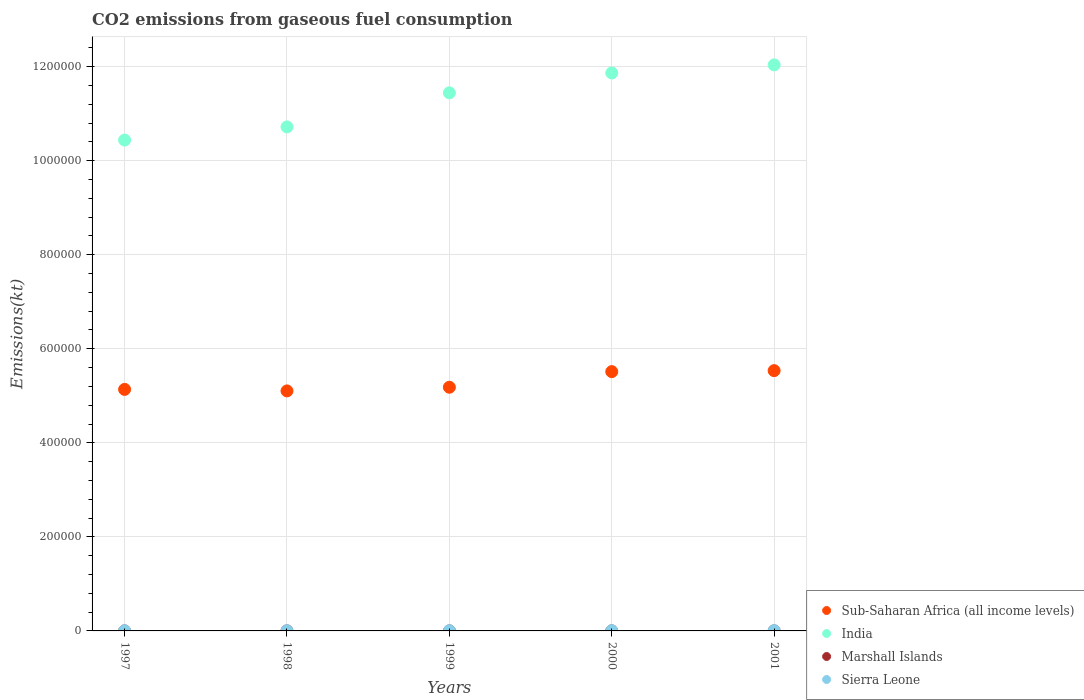How many different coloured dotlines are there?
Provide a succinct answer. 4. What is the amount of CO2 emitted in Sierra Leone in 2001?
Ensure brevity in your answer.  568.38. Across all years, what is the maximum amount of CO2 emitted in Marshall Islands?
Your answer should be very brief. 80.67. Across all years, what is the minimum amount of CO2 emitted in India?
Give a very brief answer. 1.04e+06. In which year was the amount of CO2 emitted in Sierra Leone maximum?
Ensure brevity in your answer.  2001. In which year was the amount of CO2 emitted in Marshall Islands minimum?
Give a very brief answer. 1997. What is the total amount of CO2 emitted in Marshall Islands in the graph?
Keep it short and to the point. 359.37. What is the difference between the amount of CO2 emitted in Marshall Islands in 1997 and that in 2000?
Your response must be concise. -11. What is the difference between the amount of CO2 emitted in Marshall Islands in 1997 and the amount of CO2 emitted in Sub-Saharan Africa (all income levels) in 2000?
Keep it short and to the point. -5.51e+05. What is the average amount of CO2 emitted in Marshall Islands per year?
Keep it short and to the point. 71.87. In the year 2001, what is the difference between the amount of CO2 emitted in India and amount of CO2 emitted in Sub-Saharan Africa (all income levels)?
Your answer should be compact. 6.50e+05. What is the ratio of the amount of CO2 emitted in Sub-Saharan Africa (all income levels) in 1998 to that in 2000?
Your answer should be compact. 0.93. Is the amount of CO2 emitted in Sierra Leone in 1999 less than that in 2001?
Provide a short and direct response. Yes. What is the difference between the highest and the second highest amount of CO2 emitted in Sierra Leone?
Your response must be concise. 143.01. What is the difference between the highest and the lowest amount of CO2 emitted in Marshall Islands?
Provide a short and direct response. 14.67. Is the sum of the amount of CO2 emitted in Sub-Saharan Africa (all income levels) in 1999 and 2000 greater than the maximum amount of CO2 emitted in Sierra Leone across all years?
Offer a terse response. Yes. Is it the case that in every year, the sum of the amount of CO2 emitted in India and amount of CO2 emitted in Sub-Saharan Africa (all income levels)  is greater than the sum of amount of CO2 emitted in Marshall Islands and amount of CO2 emitted in Sierra Leone?
Make the answer very short. Yes. Is it the case that in every year, the sum of the amount of CO2 emitted in Sub-Saharan Africa (all income levels) and amount of CO2 emitted in Sierra Leone  is greater than the amount of CO2 emitted in India?
Make the answer very short. No. Is the amount of CO2 emitted in Marshall Islands strictly less than the amount of CO2 emitted in Sub-Saharan Africa (all income levels) over the years?
Offer a very short reply. Yes. How many dotlines are there?
Make the answer very short. 4. How many years are there in the graph?
Your response must be concise. 5. What is the difference between two consecutive major ticks on the Y-axis?
Keep it short and to the point. 2.00e+05. Does the graph contain any zero values?
Make the answer very short. No. Where does the legend appear in the graph?
Your answer should be very brief. Bottom right. How many legend labels are there?
Make the answer very short. 4. How are the legend labels stacked?
Offer a terse response. Vertical. What is the title of the graph?
Ensure brevity in your answer.  CO2 emissions from gaseous fuel consumption. Does "Sweden" appear as one of the legend labels in the graph?
Your response must be concise. No. What is the label or title of the Y-axis?
Your answer should be compact. Emissions(kt). What is the Emissions(kt) in Sub-Saharan Africa (all income levels) in 1997?
Keep it short and to the point. 5.14e+05. What is the Emissions(kt) in India in 1997?
Ensure brevity in your answer.  1.04e+06. What is the Emissions(kt) in Marshall Islands in 1997?
Offer a terse response. 66.01. What is the Emissions(kt) in Sierra Leone in 1997?
Provide a short and direct response. 392.37. What is the Emissions(kt) in Sub-Saharan Africa (all income levels) in 1998?
Make the answer very short. 5.10e+05. What is the Emissions(kt) of India in 1998?
Provide a short and direct response. 1.07e+06. What is the Emissions(kt) in Marshall Islands in 1998?
Offer a very short reply. 69.67. What is the Emissions(kt) in Sierra Leone in 1998?
Ensure brevity in your answer.  366.7. What is the Emissions(kt) of Sub-Saharan Africa (all income levels) in 1999?
Your answer should be very brief. 5.18e+05. What is the Emissions(kt) in India in 1999?
Keep it short and to the point. 1.14e+06. What is the Emissions(kt) of Marshall Islands in 1999?
Give a very brief answer. 66.01. What is the Emissions(kt) of Sierra Leone in 1999?
Offer a very short reply. 352.03. What is the Emissions(kt) of Sub-Saharan Africa (all income levels) in 2000?
Your answer should be compact. 5.51e+05. What is the Emissions(kt) of India in 2000?
Provide a succinct answer. 1.19e+06. What is the Emissions(kt) in Marshall Islands in 2000?
Your answer should be compact. 77.01. What is the Emissions(kt) of Sierra Leone in 2000?
Provide a succinct answer. 425.37. What is the Emissions(kt) in Sub-Saharan Africa (all income levels) in 2001?
Provide a short and direct response. 5.54e+05. What is the Emissions(kt) of India in 2001?
Keep it short and to the point. 1.20e+06. What is the Emissions(kt) of Marshall Islands in 2001?
Offer a very short reply. 80.67. What is the Emissions(kt) of Sierra Leone in 2001?
Give a very brief answer. 568.38. Across all years, what is the maximum Emissions(kt) of Sub-Saharan Africa (all income levels)?
Ensure brevity in your answer.  5.54e+05. Across all years, what is the maximum Emissions(kt) in India?
Provide a succinct answer. 1.20e+06. Across all years, what is the maximum Emissions(kt) in Marshall Islands?
Make the answer very short. 80.67. Across all years, what is the maximum Emissions(kt) in Sierra Leone?
Ensure brevity in your answer.  568.38. Across all years, what is the minimum Emissions(kt) of Sub-Saharan Africa (all income levels)?
Offer a very short reply. 5.10e+05. Across all years, what is the minimum Emissions(kt) in India?
Keep it short and to the point. 1.04e+06. Across all years, what is the minimum Emissions(kt) of Marshall Islands?
Ensure brevity in your answer.  66.01. Across all years, what is the minimum Emissions(kt) in Sierra Leone?
Offer a terse response. 352.03. What is the total Emissions(kt) of Sub-Saharan Africa (all income levels) in the graph?
Keep it short and to the point. 2.65e+06. What is the total Emissions(kt) of India in the graph?
Provide a short and direct response. 5.65e+06. What is the total Emissions(kt) in Marshall Islands in the graph?
Your answer should be compact. 359.37. What is the total Emissions(kt) in Sierra Leone in the graph?
Offer a terse response. 2104.86. What is the difference between the Emissions(kt) in Sub-Saharan Africa (all income levels) in 1997 and that in 1998?
Offer a very short reply. 3200.52. What is the difference between the Emissions(kt) in India in 1997 and that in 1998?
Ensure brevity in your answer.  -2.80e+04. What is the difference between the Emissions(kt) in Marshall Islands in 1997 and that in 1998?
Give a very brief answer. -3.67. What is the difference between the Emissions(kt) of Sierra Leone in 1997 and that in 1998?
Offer a terse response. 25.67. What is the difference between the Emissions(kt) of Sub-Saharan Africa (all income levels) in 1997 and that in 1999?
Offer a terse response. -4576.38. What is the difference between the Emissions(kt) in India in 1997 and that in 1999?
Ensure brevity in your answer.  -1.00e+05. What is the difference between the Emissions(kt) in Sierra Leone in 1997 and that in 1999?
Make the answer very short. 40.34. What is the difference between the Emissions(kt) in Sub-Saharan Africa (all income levels) in 1997 and that in 2000?
Provide a short and direct response. -3.78e+04. What is the difference between the Emissions(kt) of India in 1997 and that in 2000?
Your answer should be compact. -1.43e+05. What is the difference between the Emissions(kt) of Marshall Islands in 1997 and that in 2000?
Offer a terse response. -11. What is the difference between the Emissions(kt) of Sierra Leone in 1997 and that in 2000?
Ensure brevity in your answer.  -33. What is the difference between the Emissions(kt) of Sub-Saharan Africa (all income levels) in 1997 and that in 2001?
Offer a terse response. -3.99e+04. What is the difference between the Emissions(kt) in India in 1997 and that in 2001?
Keep it short and to the point. -1.60e+05. What is the difference between the Emissions(kt) in Marshall Islands in 1997 and that in 2001?
Keep it short and to the point. -14.67. What is the difference between the Emissions(kt) of Sierra Leone in 1997 and that in 2001?
Your answer should be very brief. -176.02. What is the difference between the Emissions(kt) in Sub-Saharan Africa (all income levels) in 1998 and that in 1999?
Offer a terse response. -7776.91. What is the difference between the Emissions(kt) of India in 1998 and that in 1999?
Offer a terse response. -7.25e+04. What is the difference between the Emissions(kt) in Marshall Islands in 1998 and that in 1999?
Give a very brief answer. 3.67. What is the difference between the Emissions(kt) in Sierra Leone in 1998 and that in 1999?
Give a very brief answer. 14.67. What is the difference between the Emissions(kt) in Sub-Saharan Africa (all income levels) in 1998 and that in 2000?
Your answer should be very brief. -4.10e+04. What is the difference between the Emissions(kt) in India in 1998 and that in 2000?
Provide a short and direct response. -1.15e+05. What is the difference between the Emissions(kt) of Marshall Islands in 1998 and that in 2000?
Offer a very short reply. -7.33. What is the difference between the Emissions(kt) in Sierra Leone in 1998 and that in 2000?
Make the answer very short. -58.67. What is the difference between the Emissions(kt) of Sub-Saharan Africa (all income levels) in 1998 and that in 2001?
Make the answer very short. -4.31e+04. What is the difference between the Emissions(kt) in India in 1998 and that in 2001?
Provide a short and direct response. -1.32e+05. What is the difference between the Emissions(kt) of Marshall Islands in 1998 and that in 2001?
Your answer should be very brief. -11. What is the difference between the Emissions(kt) of Sierra Leone in 1998 and that in 2001?
Offer a very short reply. -201.69. What is the difference between the Emissions(kt) of Sub-Saharan Africa (all income levels) in 1999 and that in 2000?
Offer a terse response. -3.32e+04. What is the difference between the Emissions(kt) in India in 1999 and that in 2000?
Offer a very short reply. -4.23e+04. What is the difference between the Emissions(kt) of Marshall Islands in 1999 and that in 2000?
Provide a short and direct response. -11. What is the difference between the Emissions(kt) in Sierra Leone in 1999 and that in 2000?
Ensure brevity in your answer.  -73.34. What is the difference between the Emissions(kt) of Sub-Saharan Africa (all income levels) in 1999 and that in 2001?
Provide a succinct answer. -3.53e+04. What is the difference between the Emissions(kt) of India in 1999 and that in 2001?
Provide a succinct answer. -5.95e+04. What is the difference between the Emissions(kt) in Marshall Islands in 1999 and that in 2001?
Your answer should be very brief. -14.67. What is the difference between the Emissions(kt) of Sierra Leone in 1999 and that in 2001?
Your answer should be very brief. -216.35. What is the difference between the Emissions(kt) in Sub-Saharan Africa (all income levels) in 2000 and that in 2001?
Your answer should be compact. -2116.98. What is the difference between the Emissions(kt) in India in 2000 and that in 2001?
Provide a short and direct response. -1.72e+04. What is the difference between the Emissions(kt) of Marshall Islands in 2000 and that in 2001?
Offer a terse response. -3.67. What is the difference between the Emissions(kt) of Sierra Leone in 2000 and that in 2001?
Provide a short and direct response. -143.01. What is the difference between the Emissions(kt) in Sub-Saharan Africa (all income levels) in 1997 and the Emissions(kt) in India in 1998?
Keep it short and to the point. -5.58e+05. What is the difference between the Emissions(kt) of Sub-Saharan Africa (all income levels) in 1997 and the Emissions(kt) of Marshall Islands in 1998?
Keep it short and to the point. 5.14e+05. What is the difference between the Emissions(kt) of Sub-Saharan Africa (all income levels) in 1997 and the Emissions(kt) of Sierra Leone in 1998?
Provide a succinct answer. 5.13e+05. What is the difference between the Emissions(kt) in India in 1997 and the Emissions(kt) in Marshall Islands in 1998?
Provide a succinct answer. 1.04e+06. What is the difference between the Emissions(kt) of India in 1997 and the Emissions(kt) of Sierra Leone in 1998?
Your answer should be compact. 1.04e+06. What is the difference between the Emissions(kt) in Marshall Islands in 1997 and the Emissions(kt) in Sierra Leone in 1998?
Give a very brief answer. -300.69. What is the difference between the Emissions(kt) of Sub-Saharan Africa (all income levels) in 1997 and the Emissions(kt) of India in 1999?
Offer a very short reply. -6.31e+05. What is the difference between the Emissions(kt) in Sub-Saharan Africa (all income levels) in 1997 and the Emissions(kt) in Marshall Islands in 1999?
Your answer should be very brief. 5.14e+05. What is the difference between the Emissions(kt) in Sub-Saharan Africa (all income levels) in 1997 and the Emissions(kt) in Sierra Leone in 1999?
Provide a succinct answer. 5.13e+05. What is the difference between the Emissions(kt) of India in 1997 and the Emissions(kt) of Marshall Islands in 1999?
Provide a succinct answer. 1.04e+06. What is the difference between the Emissions(kt) of India in 1997 and the Emissions(kt) of Sierra Leone in 1999?
Make the answer very short. 1.04e+06. What is the difference between the Emissions(kt) in Marshall Islands in 1997 and the Emissions(kt) in Sierra Leone in 1999?
Offer a terse response. -286.03. What is the difference between the Emissions(kt) of Sub-Saharan Africa (all income levels) in 1997 and the Emissions(kt) of India in 2000?
Make the answer very short. -6.73e+05. What is the difference between the Emissions(kt) in Sub-Saharan Africa (all income levels) in 1997 and the Emissions(kt) in Marshall Islands in 2000?
Ensure brevity in your answer.  5.14e+05. What is the difference between the Emissions(kt) in Sub-Saharan Africa (all income levels) in 1997 and the Emissions(kt) in Sierra Leone in 2000?
Give a very brief answer. 5.13e+05. What is the difference between the Emissions(kt) of India in 1997 and the Emissions(kt) of Marshall Islands in 2000?
Keep it short and to the point. 1.04e+06. What is the difference between the Emissions(kt) of India in 1997 and the Emissions(kt) of Sierra Leone in 2000?
Make the answer very short. 1.04e+06. What is the difference between the Emissions(kt) of Marshall Islands in 1997 and the Emissions(kt) of Sierra Leone in 2000?
Make the answer very short. -359.37. What is the difference between the Emissions(kt) in Sub-Saharan Africa (all income levels) in 1997 and the Emissions(kt) in India in 2001?
Your answer should be compact. -6.90e+05. What is the difference between the Emissions(kt) of Sub-Saharan Africa (all income levels) in 1997 and the Emissions(kt) of Marshall Islands in 2001?
Give a very brief answer. 5.14e+05. What is the difference between the Emissions(kt) in Sub-Saharan Africa (all income levels) in 1997 and the Emissions(kt) in Sierra Leone in 2001?
Ensure brevity in your answer.  5.13e+05. What is the difference between the Emissions(kt) in India in 1997 and the Emissions(kt) in Marshall Islands in 2001?
Give a very brief answer. 1.04e+06. What is the difference between the Emissions(kt) in India in 1997 and the Emissions(kt) in Sierra Leone in 2001?
Make the answer very short. 1.04e+06. What is the difference between the Emissions(kt) of Marshall Islands in 1997 and the Emissions(kt) of Sierra Leone in 2001?
Ensure brevity in your answer.  -502.38. What is the difference between the Emissions(kt) in Sub-Saharan Africa (all income levels) in 1998 and the Emissions(kt) in India in 1999?
Provide a succinct answer. -6.34e+05. What is the difference between the Emissions(kt) of Sub-Saharan Africa (all income levels) in 1998 and the Emissions(kt) of Marshall Islands in 1999?
Provide a succinct answer. 5.10e+05. What is the difference between the Emissions(kt) in Sub-Saharan Africa (all income levels) in 1998 and the Emissions(kt) in Sierra Leone in 1999?
Your answer should be compact. 5.10e+05. What is the difference between the Emissions(kt) in India in 1998 and the Emissions(kt) in Marshall Islands in 1999?
Your answer should be compact. 1.07e+06. What is the difference between the Emissions(kt) in India in 1998 and the Emissions(kt) in Sierra Leone in 1999?
Your response must be concise. 1.07e+06. What is the difference between the Emissions(kt) of Marshall Islands in 1998 and the Emissions(kt) of Sierra Leone in 1999?
Provide a short and direct response. -282.36. What is the difference between the Emissions(kt) of Sub-Saharan Africa (all income levels) in 1998 and the Emissions(kt) of India in 2000?
Provide a succinct answer. -6.76e+05. What is the difference between the Emissions(kt) of Sub-Saharan Africa (all income levels) in 1998 and the Emissions(kt) of Marshall Islands in 2000?
Your response must be concise. 5.10e+05. What is the difference between the Emissions(kt) in Sub-Saharan Africa (all income levels) in 1998 and the Emissions(kt) in Sierra Leone in 2000?
Give a very brief answer. 5.10e+05. What is the difference between the Emissions(kt) in India in 1998 and the Emissions(kt) in Marshall Islands in 2000?
Keep it short and to the point. 1.07e+06. What is the difference between the Emissions(kt) of India in 1998 and the Emissions(kt) of Sierra Leone in 2000?
Make the answer very short. 1.07e+06. What is the difference between the Emissions(kt) of Marshall Islands in 1998 and the Emissions(kt) of Sierra Leone in 2000?
Give a very brief answer. -355.7. What is the difference between the Emissions(kt) of Sub-Saharan Africa (all income levels) in 1998 and the Emissions(kt) of India in 2001?
Keep it short and to the point. -6.93e+05. What is the difference between the Emissions(kt) in Sub-Saharan Africa (all income levels) in 1998 and the Emissions(kt) in Marshall Islands in 2001?
Provide a succinct answer. 5.10e+05. What is the difference between the Emissions(kt) in Sub-Saharan Africa (all income levels) in 1998 and the Emissions(kt) in Sierra Leone in 2001?
Keep it short and to the point. 5.10e+05. What is the difference between the Emissions(kt) in India in 1998 and the Emissions(kt) in Marshall Islands in 2001?
Keep it short and to the point. 1.07e+06. What is the difference between the Emissions(kt) of India in 1998 and the Emissions(kt) of Sierra Leone in 2001?
Give a very brief answer. 1.07e+06. What is the difference between the Emissions(kt) of Marshall Islands in 1998 and the Emissions(kt) of Sierra Leone in 2001?
Keep it short and to the point. -498.71. What is the difference between the Emissions(kt) of Sub-Saharan Africa (all income levels) in 1999 and the Emissions(kt) of India in 2000?
Keep it short and to the point. -6.68e+05. What is the difference between the Emissions(kt) in Sub-Saharan Africa (all income levels) in 1999 and the Emissions(kt) in Marshall Islands in 2000?
Ensure brevity in your answer.  5.18e+05. What is the difference between the Emissions(kt) of Sub-Saharan Africa (all income levels) in 1999 and the Emissions(kt) of Sierra Leone in 2000?
Keep it short and to the point. 5.18e+05. What is the difference between the Emissions(kt) of India in 1999 and the Emissions(kt) of Marshall Islands in 2000?
Your answer should be compact. 1.14e+06. What is the difference between the Emissions(kt) in India in 1999 and the Emissions(kt) in Sierra Leone in 2000?
Your response must be concise. 1.14e+06. What is the difference between the Emissions(kt) of Marshall Islands in 1999 and the Emissions(kt) of Sierra Leone in 2000?
Provide a short and direct response. -359.37. What is the difference between the Emissions(kt) of Sub-Saharan Africa (all income levels) in 1999 and the Emissions(kt) of India in 2001?
Ensure brevity in your answer.  -6.86e+05. What is the difference between the Emissions(kt) in Sub-Saharan Africa (all income levels) in 1999 and the Emissions(kt) in Marshall Islands in 2001?
Offer a terse response. 5.18e+05. What is the difference between the Emissions(kt) in Sub-Saharan Africa (all income levels) in 1999 and the Emissions(kt) in Sierra Leone in 2001?
Your answer should be very brief. 5.18e+05. What is the difference between the Emissions(kt) of India in 1999 and the Emissions(kt) of Marshall Islands in 2001?
Make the answer very short. 1.14e+06. What is the difference between the Emissions(kt) in India in 1999 and the Emissions(kt) in Sierra Leone in 2001?
Ensure brevity in your answer.  1.14e+06. What is the difference between the Emissions(kt) in Marshall Islands in 1999 and the Emissions(kt) in Sierra Leone in 2001?
Make the answer very short. -502.38. What is the difference between the Emissions(kt) of Sub-Saharan Africa (all income levels) in 2000 and the Emissions(kt) of India in 2001?
Your answer should be compact. -6.52e+05. What is the difference between the Emissions(kt) of Sub-Saharan Africa (all income levels) in 2000 and the Emissions(kt) of Marshall Islands in 2001?
Your response must be concise. 5.51e+05. What is the difference between the Emissions(kt) in Sub-Saharan Africa (all income levels) in 2000 and the Emissions(kt) in Sierra Leone in 2001?
Offer a terse response. 5.51e+05. What is the difference between the Emissions(kt) of India in 2000 and the Emissions(kt) of Marshall Islands in 2001?
Provide a short and direct response. 1.19e+06. What is the difference between the Emissions(kt) of India in 2000 and the Emissions(kt) of Sierra Leone in 2001?
Your response must be concise. 1.19e+06. What is the difference between the Emissions(kt) of Marshall Islands in 2000 and the Emissions(kt) of Sierra Leone in 2001?
Ensure brevity in your answer.  -491.38. What is the average Emissions(kt) in Sub-Saharan Africa (all income levels) per year?
Ensure brevity in your answer.  5.29e+05. What is the average Emissions(kt) in India per year?
Ensure brevity in your answer.  1.13e+06. What is the average Emissions(kt) of Marshall Islands per year?
Your response must be concise. 71.87. What is the average Emissions(kt) of Sierra Leone per year?
Offer a terse response. 420.97. In the year 1997, what is the difference between the Emissions(kt) in Sub-Saharan Africa (all income levels) and Emissions(kt) in India?
Offer a very short reply. -5.30e+05. In the year 1997, what is the difference between the Emissions(kt) in Sub-Saharan Africa (all income levels) and Emissions(kt) in Marshall Islands?
Your answer should be compact. 5.14e+05. In the year 1997, what is the difference between the Emissions(kt) of Sub-Saharan Africa (all income levels) and Emissions(kt) of Sierra Leone?
Offer a very short reply. 5.13e+05. In the year 1997, what is the difference between the Emissions(kt) of India and Emissions(kt) of Marshall Islands?
Your answer should be very brief. 1.04e+06. In the year 1997, what is the difference between the Emissions(kt) in India and Emissions(kt) in Sierra Leone?
Your response must be concise. 1.04e+06. In the year 1997, what is the difference between the Emissions(kt) of Marshall Islands and Emissions(kt) of Sierra Leone?
Provide a succinct answer. -326.36. In the year 1998, what is the difference between the Emissions(kt) of Sub-Saharan Africa (all income levels) and Emissions(kt) of India?
Your answer should be very brief. -5.61e+05. In the year 1998, what is the difference between the Emissions(kt) in Sub-Saharan Africa (all income levels) and Emissions(kt) in Marshall Islands?
Offer a very short reply. 5.10e+05. In the year 1998, what is the difference between the Emissions(kt) in Sub-Saharan Africa (all income levels) and Emissions(kt) in Sierra Leone?
Give a very brief answer. 5.10e+05. In the year 1998, what is the difference between the Emissions(kt) of India and Emissions(kt) of Marshall Islands?
Ensure brevity in your answer.  1.07e+06. In the year 1998, what is the difference between the Emissions(kt) in India and Emissions(kt) in Sierra Leone?
Ensure brevity in your answer.  1.07e+06. In the year 1998, what is the difference between the Emissions(kt) of Marshall Islands and Emissions(kt) of Sierra Leone?
Offer a terse response. -297.03. In the year 1999, what is the difference between the Emissions(kt) of Sub-Saharan Africa (all income levels) and Emissions(kt) of India?
Your response must be concise. -6.26e+05. In the year 1999, what is the difference between the Emissions(kt) of Sub-Saharan Africa (all income levels) and Emissions(kt) of Marshall Islands?
Your answer should be very brief. 5.18e+05. In the year 1999, what is the difference between the Emissions(kt) in Sub-Saharan Africa (all income levels) and Emissions(kt) in Sierra Leone?
Offer a terse response. 5.18e+05. In the year 1999, what is the difference between the Emissions(kt) of India and Emissions(kt) of Marshall Islands?
Offer a very short reply. 1.14e+06. In the year 1999, what is the difference between the Emissions(kt) in India and Emissions(kt) in Sierra Leone?
Offer a very short reply. 1.14e+06. In the year 1999, what is the difference between the Emissions(kt) of Marshall Islands and Emissions(kt) of Sierra Leone?
Give a very brief answer. -286.03. In the year 2000, what is the difference between the Emissions(kt) in Sub-Saharan Africa (all income levels) and Emissions(kt) in India?
Your answer should be compact. -6.35e+05. In the year 2000, what is the difference between the Emissions(kt) in Sub-Saharan Africa (all income levels) and Emissions(kt) in Marshall Islands?
Offer a very short reply. 5.51e+05. In the year 2000, what is the difference between the Emissions(kt) in Sub-Saharan Africa (all income levels) and Emissions(kt) in Sierra Leone?
Keep it short and to the point. 5.51e+05. In the year 2000, what is the difference between the Emissions(kt) of India and Emissions(kt) of Marshall Islands?
Your answer should be very brief. 1.19e+06. In the year 2000, what is the difference between the Emissions(kt) of India and Emissions(kt) of Sierra Leone?
Keep it short and to the point. 1.19e+06. In the year 2000, what is the difference between the Emissions(kt) of Marshall Islands and Emissions(kt) of Sierra Leone?
Your answer should be compact. -348.37. In the year 2001, what is the difference between the Emissions(kt) in Sub-Saharan Africa (all income levels) and Emissions(kt) in India?
Keep it short and to the point. -6.50e+05. In the year 2001, what is the difference between the Emissions(kt) in Sub-Saharan Africa (all income levels) and Emissions(kt) in Marshall Islands?
Give a very brief answer. 5.53e+05. In the year 2001, what is the difference between the Emissions(kt) of Sub-Saharan Africa (all income levels) and Emissions(kt) of Sierra Leone?
Give a very brief answer. 5.53e+05. In the year 2001, what is the difference between the Emissions(kt) in India and Emissions(kt) in Marshall Islands?
Your response must be concise. 1.20e+06. In the year 2001, what is the difference between the Emissions(kt) in India and Emissions(kt) in Sierra Leone?
Make the answer very short. 1.20e+06. In the year 2001, what is the difference between the Emissions(kt) in Marshall Islands and Emissions(kt) in Sierra Leone?
Your response must be concise. -487.71. What is the ratio of the Emissions(kt) in India in 1997 to that in 1998?
Keep it short and to the point. 0.97. What is the ratio of the Emissions(kt) of Marshall Islands in 1997 to that in 1998?
Provide a succinct answer. 0.95. What is the ratio of the Emissions(kt) of Sierra Leone in 1997 to that in 1998?
Provide a succinct answer. 1.07. What is the ratio of the Emissions(kt) in Sub-Saharan Africa (all income levels) in 1997 to that in 1999?
Provide a short and direct response. 0.99. What is the ratio of the Emissions(kt) of India in 1997 to that in 1999?
Offer a very short reply. 0.91. What is the ratio of the Emissions(kt) in Marshall Islands in 1997 to that in 1999?
Make the answer very short. 1. What is the ratio of the Emissions(kt) in Sierra Leone in 1997 to that in 1999?
Provide a short and direct response. 1.11. What is the ratio of the Emissions(kt) in Sub-Saharan Africa (all income levels) in 1997 to that in 2000?
Offer a very short reply. 0.93. What is the ratio of the Emissions(kt) in India in 1997 to that in 2000?
Keep it short and to the point. 0.88. What is the ratio of the Emissions(kt) of Marshall Islands in 1997 to that in 2000?
Your answer should be compact. 0.86. What is the ratio of the Emissions(kt) in Sierra Leone in 1997 to that in 2000?
Your answer should be compact. 0.92. What is the ratio of the Emissions(kt) of Sub-Saharan Africa (all income levels) in 1997 to that in 2001?
Keep it short and to the point. 0.93. What is the ratio of the Emissions(kt) in India in 1997 to that in 2001?
Your response must be concise. 0.87. What is the ratio of the Emissions(kt) of Marshall Islands in 1997 to that in 2001?
Your answer should be compact. 0.82. What is the ratio of the Emissions(kt) of Sierra Leone in 1997 to that in 2001?
Your answer should be compact. 0.69. What is the ratio of the Emissions(kt) of Sub-Saharan Africa (all income levels) in 1998 to that in 1999?
Ensure brevity in your answer.  0.98. What is the ratio of the Emissions(kt) of India in 1998 to that in 1999?
Provide a succinct answer. 0.94. What is the ratio of the Emissions(kt) in Marshall Islands in 1998 to that in 1999?
Your response must be concise. 1.06. What is the ratio of the Emissions(kt) of Sierra Leone in 1998 to that in 1999?
Provide a succinct answer. 1.04. What is the ratio of the Emissions(kt) of Sub-Saharan Africa (all income levels) in 1998 to that in 2000?
Provide a succinct answer. 0.93. What is the ratio of the Emissions(kt) in India in 1998 to that in 2000?
Your response must be concise. 0.9. What is the ratio of the Emissions(kt) of Marshall Islands in 1998 to that in 2000?
Ensure brevity in your answer.  0.9. What is the ratio of the Emissions(kt) in Sierra Leone in 1998 to that in 2000?
Give a very brief answer. 0.86. What is the ratio of the Emissions(kt) of Sub-Saharan Africa (all income levels) in 1998 to that in 2001?
Offer a very short reply. 0.92. What is the ratio of the Emissions(kt) in India in 1998 to that in 2001?
Give a very brief answer. 0.89. What is the ratio of the Emissions(kt) in Marshall Islands in 1998 to that in 2001?
Ensure brevity in your answer.  0.86. What is the ratio of the Emissions(kt) of Sierra Leone in 1998 to that in 2001?
Offer a terse response. 0.65. What is the ratio of the Emissions(kt) in Sub-Saharan Africa (all income levels) in 1999 to that in 2000?
Ensure brevity in your answer.  0.94. What is the ratio of the Emissions(kt) in India in 1999 to that in 2000?
Offer a terse response. 0.96. What is the ratio of the Emissions(kt) of Marshall Islands in 1999 to that in 2000?
Your answer should be very brief. 0.86. What is the ratio of the Emissions(kt) in Sierra Leone in 1999 to that in 2000?
Your response must be concise. 0.83. What is the ratio of the Emissions(kt) in Sub-Saharan Africa (all income levels) in 1999 to that in 2001?
Give a very brief answer. 0.94. What is the ratio of the Emissions(kt) of India in 1999 to that in 2001?
Your response must be concise. 0.95. What is the ratio of the Emissions(kt) in Marshall Islands in 1999 to that in 2001?
Give a very brief answer. 0.82. What is the ratio of the Emissions(kt) in Sierra Leone in 1999 to that in 2001?
Provide a succinct answer. 0.62. What is the ratio of the Emissions(kt) in India in 2000 to that in 2001?
Make the answer very short. 0.99. What is the ratio of the Emissions(kt) of Marshall Islands in 2000 to that in 2001?
Make the answer very short. 0.95. What is the ratio of the Emissions(kt) in Sierra Leone in 2000 to that in 2001?
Ensure brevity in your answer.  0.75. What is the difference between the highest and the second highest Emissions(kt) in Sub-Saharan Africa (all income levels)?
Give a very brief answer. 2116.98. What is the difference between the highest and the second highest Emissions(kt) of India?
Offer a terse response. 1.72e+04. What is the difference between the highest and the second highest Emissions(kt) in Marshall Islands?
Provide a short and direct response. 3.67. What is the difference between the highest and the second highest Emissions(kt) of Sierra Leone?
Give a very brief answer. 143.01. What is the difference between the highest and the lowest Emissions(kt) in Sub-Saharan Africa (all income levels)?
Give a very brief answer. 4.31e+04. What is the difference between the highest and the lowest Emissions(kt) in India?
Offer a very short reply. 1.60e+05. What is the difference between the highest and the lowest Emissions(kt) of Marshall Islands?
Offer a very short reply. 14.67. What is the difference between the highest and the lowest Emissions(kt) of Sierra Leone?
Offer a terse response. 216.35. 